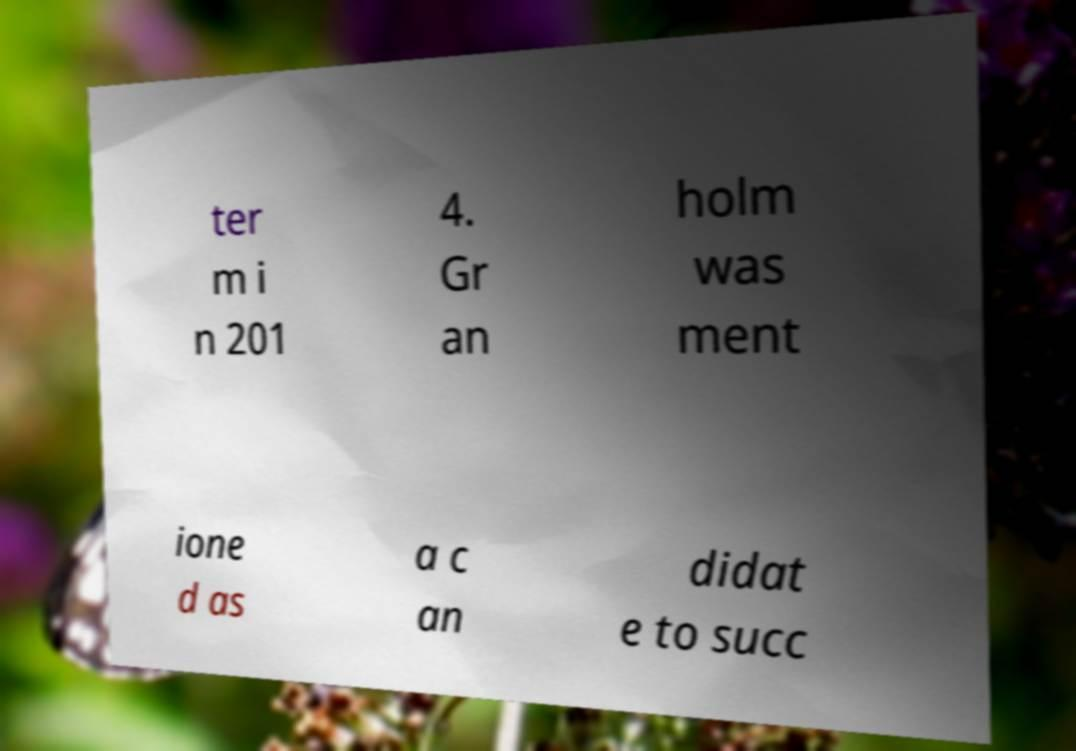Please identify and transcribe the text found in this image. ter m i n 201 4. Gr an holm was ment ione d as a c an didat e to succ 